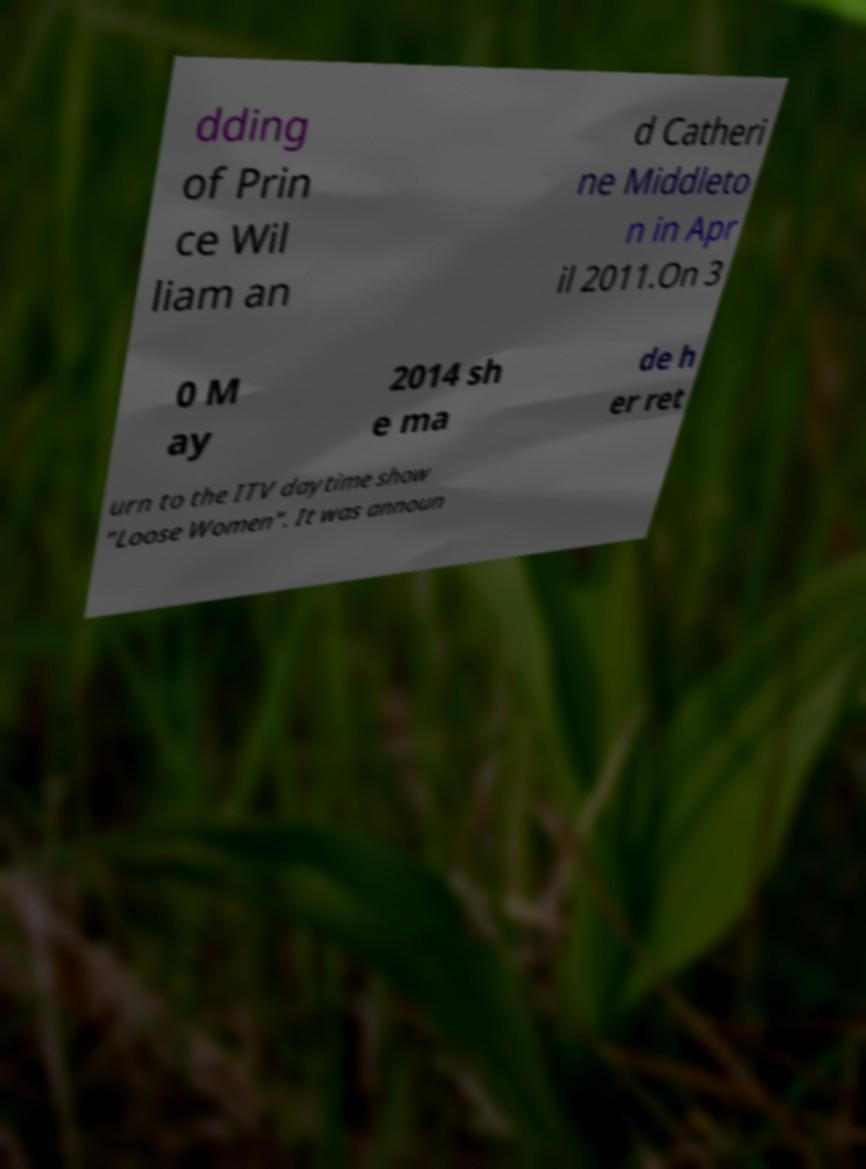What messages or text are displayed in this image? I need them in a readable, typed format. dding of Prin ce Wil liam an d Catheri ne Middleto n in Apr il 2011.On 3 0 M ay 2014 sh e ma de h er ret urn to the ITV daytime show "Loose Women". It was announ 